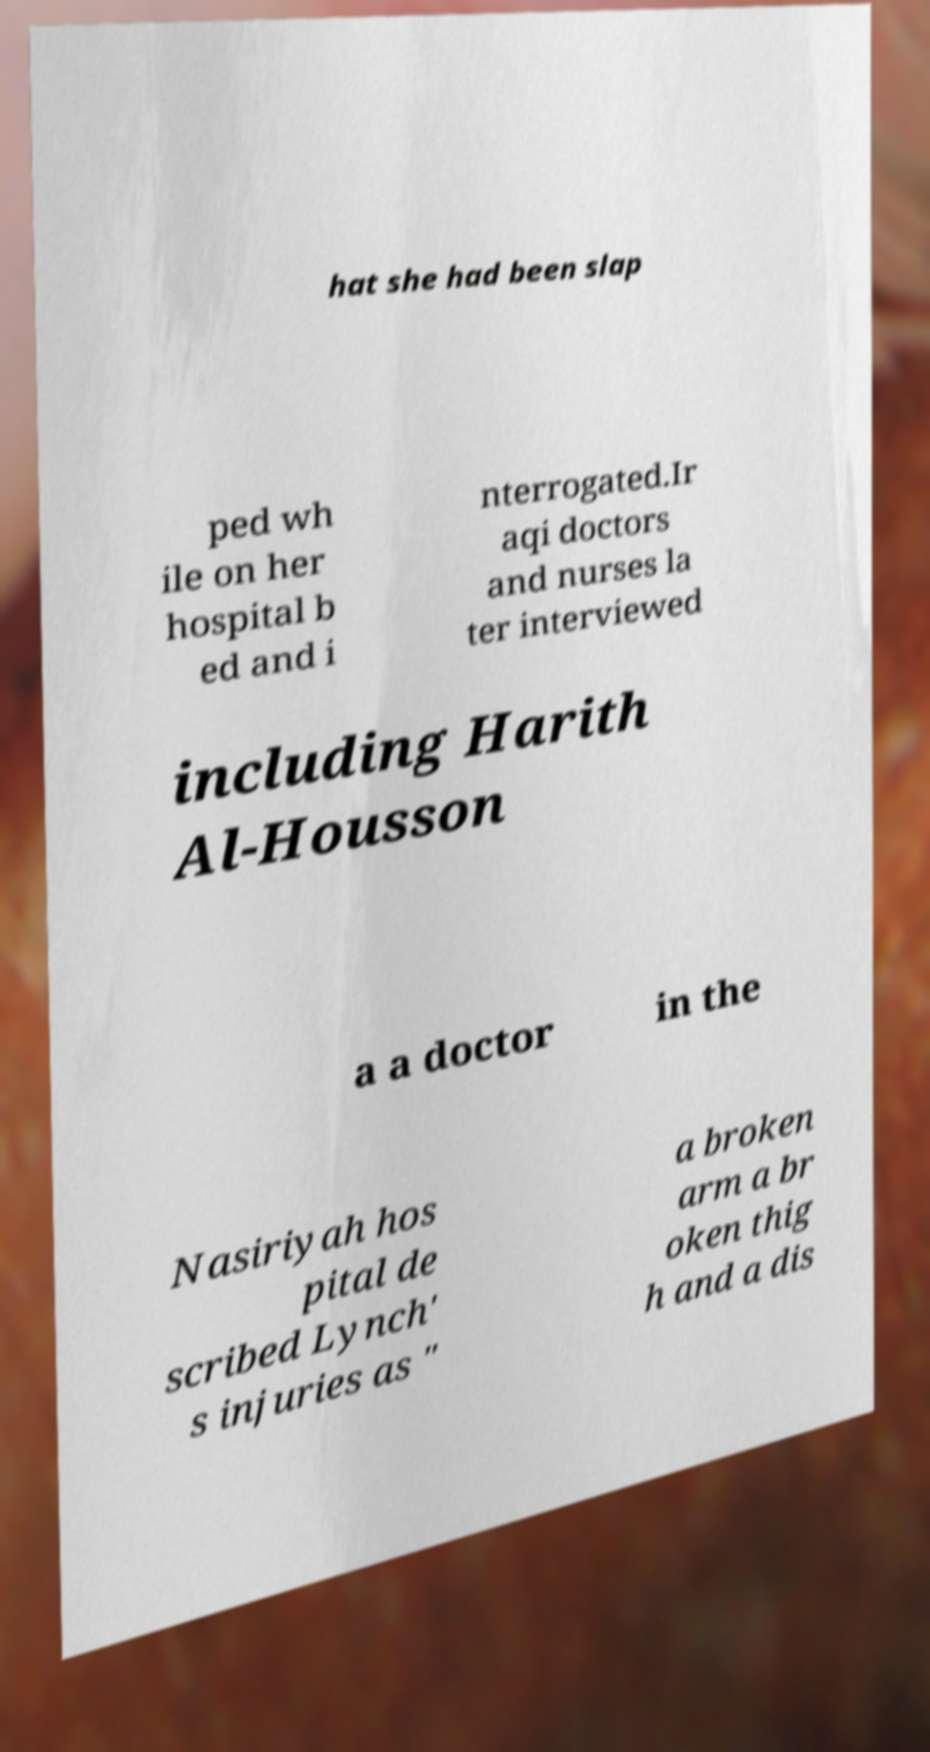Please identify and transcribe the text found in this image. hat she had been slap ped wh ile on her hospital b ed and i nterrogated.Ir aqi doctors and nurses la ter interviewed including Harith Al-Housson a a doctor in the Nasiriyah hos pital de scribed Lynch' s injuries as " a broken arm a br oken thig h and a dis 